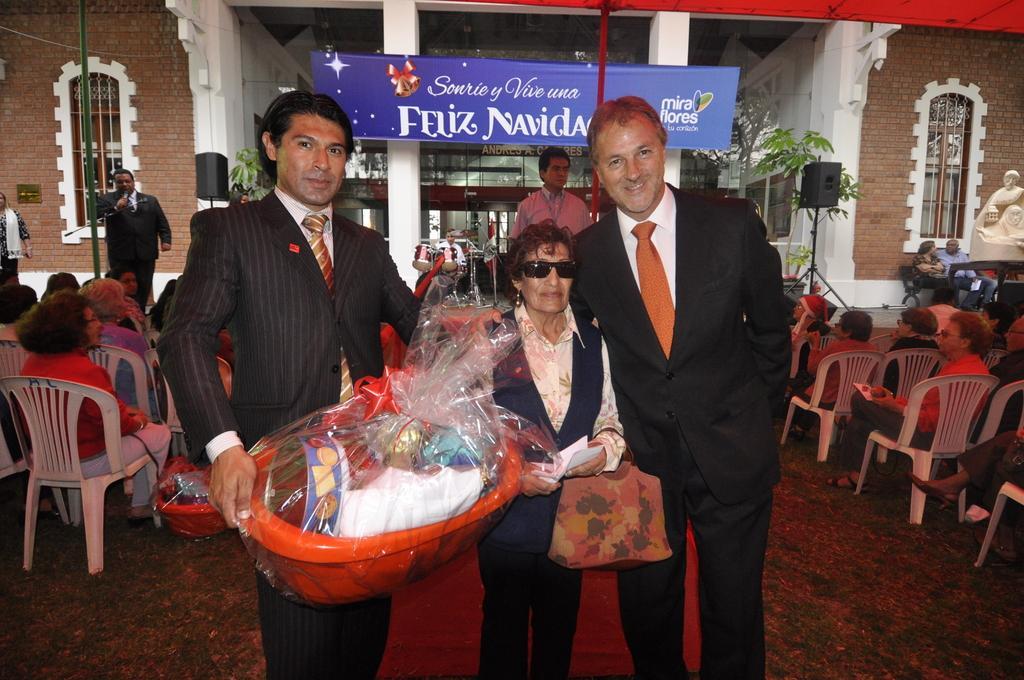Could you give a brief overview of what you see in this image? In this picture 3 persons are highlighted. This person in black suit holding a basket with a cover wrap. This woman wore goggles, holding a paper and carrying a bag. This man wore black suit, black trouser. A group of people are sitting on chairs. This is a building with brick walls and there is a window. The man in black suit is holding mic. Sound box. Plants are in green color. Pillars are in white color. This banner is attached with this 2 pillars. Musical instrument. Sculpture. These 2 persons are sitting on a chair. 